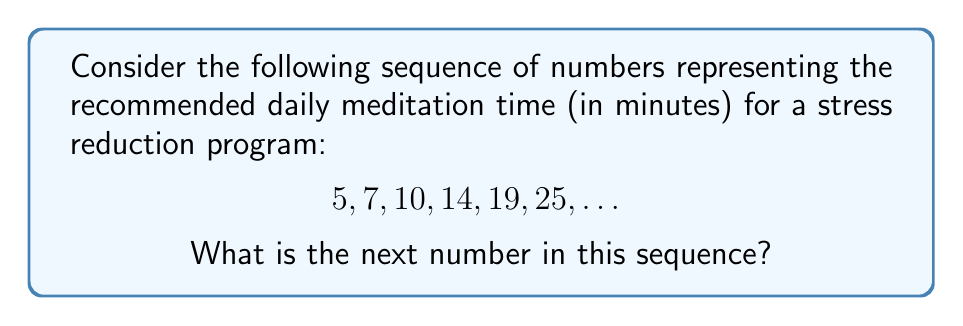Can you answer this question? To find the rule in this sequence and determine the next number, let's follow these steps:

1) First, let's calculate the differences between consecutive terms:
   $7 - 5 = 2$
   $10 - 7 = 3$
   $14 - 10 = 4$
   $19 - 14 = 5$
   $25 - 19 = 6$

2) We can observe that the differences themselves form a sequence:
   2, 3, 4, 5, 6

3) This sequence of differences is an arithmetic sequence with a common difference of 1.

4) The rule for this sequence is: each term is obtained by adding the next consecutive integer to the previous term.

5) To find the next number in the original sequence, we need to add the next number in the difference sequence (which would be 7) to the last term of the original sequence:

   $25 + 7 = 32$

This progression in meditation time allows for a gradual increase, which is ideal for a retired parent who wants to emphasize the importance of taking time for oneself without overwhelming sudden changes.
Answer: 32 